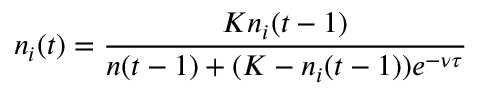<formula> <loc_0><loc_0><loc_500><loc_500>n _ { i } ( t ) = \frac { K n _ { i } ( t - 1 ) } { n ( t - 1 ) + ( K - n _ { i } ( t - 1 ) ) e ^ { - \nu \tau } }</formula> 